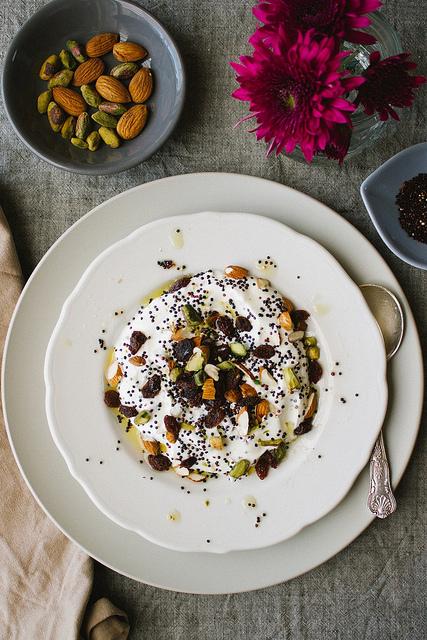Is this a main course or dessert food?
Give a very brief answer. Dessert. What are those two things on the top right?
Keep it brief. Flowers. What color is prevalent?
Concise answer only. White. What utensil is on the plate?
Give a very brief answer. Spoon. What color is the flower in this picture?
Concise answer only. Pink. What type of flower is in the picture?
Short answer required. Daisy. Is this meal fine dining?
Short answer required. Yes. What color is the flowers in the bouquet?
Quick response, please. Pink. Why would someone eat this?
Keep it brief. Hunger. Is this a healthy dish?
Concise answer only. Yes. Is broccoli being served?
Answer briefly. No. Does this look like dessert?
Be succinct. No. 